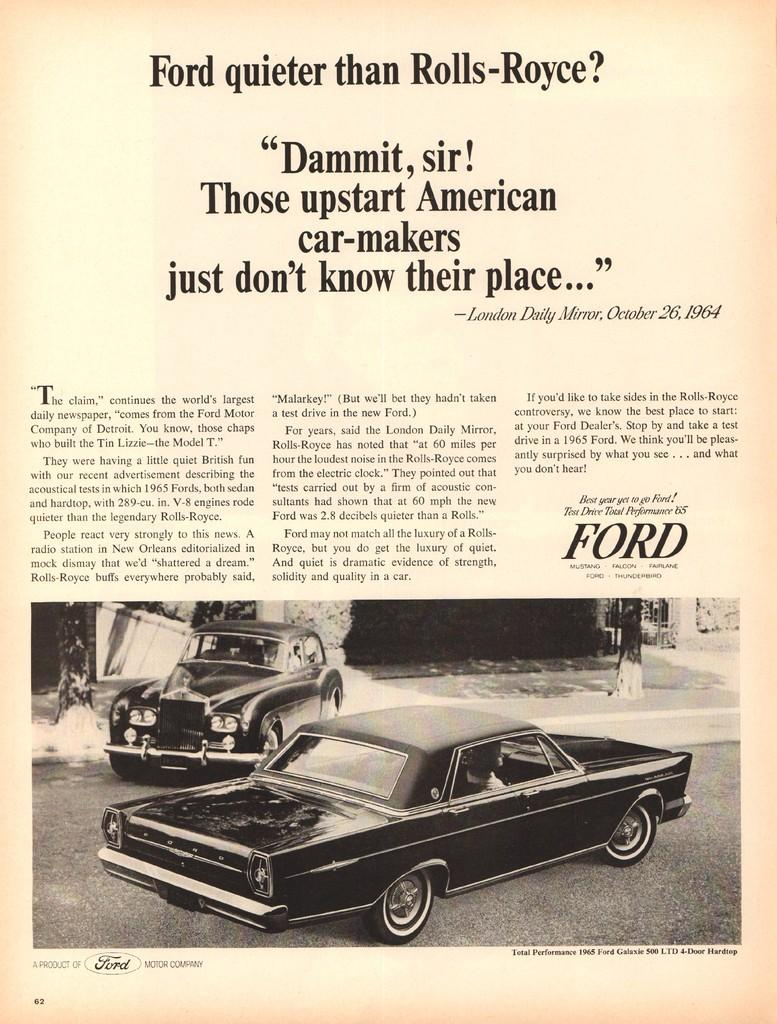What type of content is present on the page? The page contains text. What else can be found on the page besides text? There is an image on the page. What is depicted in the image? The image contains two cars. What is the setting of the image? The image depicts a road. How does the page control the flow of traffic on the road? The page does not control the flow of traffic; it is a static image and text. 